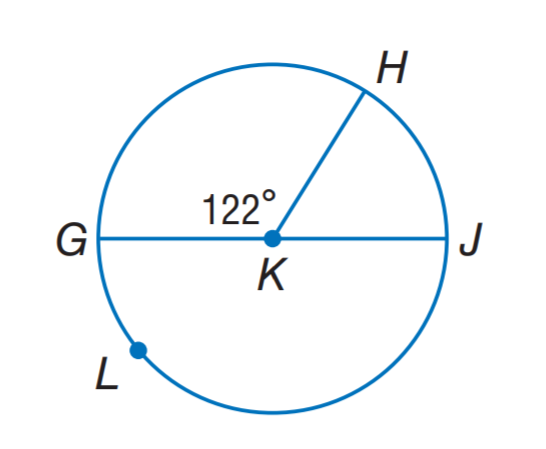Question: G J is a diameter of \odot K. Find m \widehat G H.
Choices:
A. 58
B. 61
C. 116
D. 122
Answer with the letter. Answer: D Question: G J is a diameter of \odot K. Find m \widehat G L H.
Choices:
A. 119
B. 122
C. 238
D. 244
Answer with the letter. Answer: C 